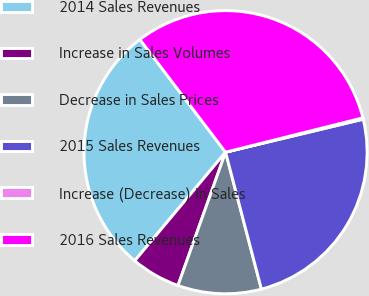Convert chart to OTSL. <chart><loc_0><loc_0><loc_500><loc_500><pie_chart><fcel>2014 Sales Revenues<fcel>Increase in Sales Volumes<fcel>Decrease in Sales Prices<fcel>2015 Sales Revenues<fcel>Increase (Decrease) in Sales<fcel>2016 Sales Revenues<nl><fcel>28.57%<fcel>5.63%<fcel>9.53%<fcel>24.67%<fcel>0.16%<fcel>31.44%<nl></chart> 